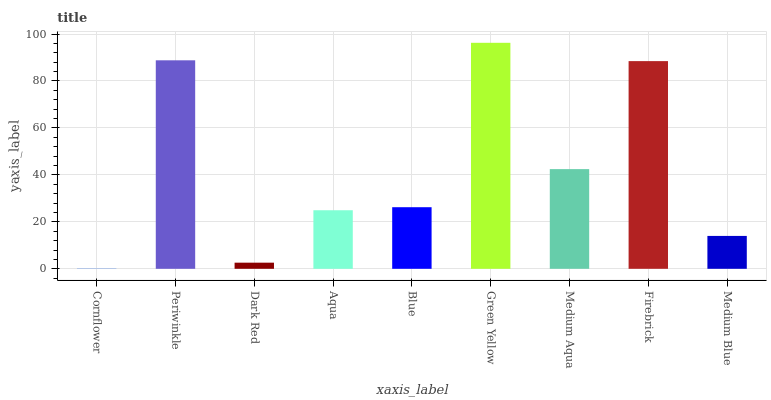Is Cornflower the minimum?
Answer yes or no. Yes. Is Green Yellow the maximum?
Answer yes or no. Yes. Is Periwinkle the minimum?
Answer yes or no. No. Is Periwinkle the maximum?
Answer yes or no. No. Is Periwinkle greater than Cornflower?
Answer yes or no. Yes. Is Cornflower less than Periwinkle?
Answer yes or no. Yes. Is Cornflower greater than Periwinkle?
Answer yes or no. No. Is Periwinkle less than Cornflower?
Answer yes or no. No. Is Blue the high median?
Answer yes or no. Yes. Is Blue the low median?
Answer yes or no. Yes. Is Periwinkle the high median?
Answer yes or no. No. Is Medium Aqua the low median?
Answer yes or no. No. 